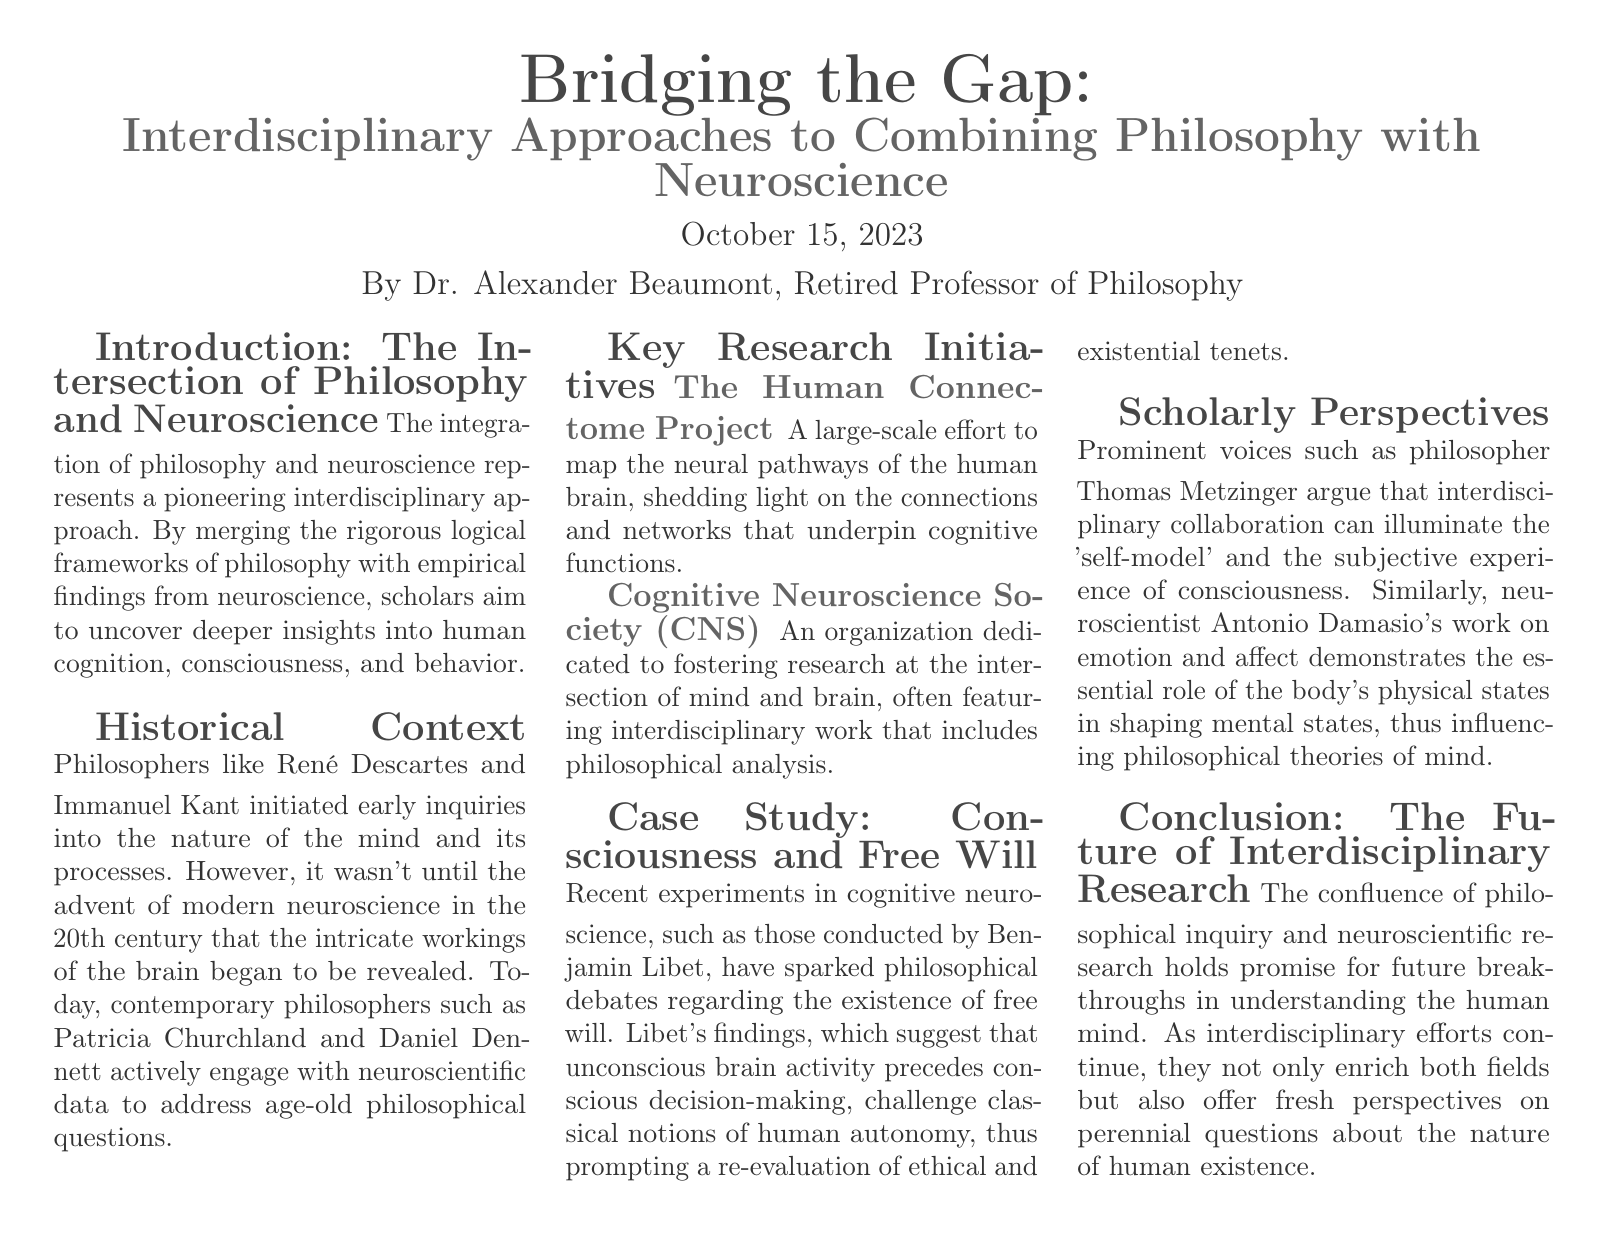What is the title of the article? The title of the article is presented at the top of the document.
Answer: Bridging the Gap: Interdisciplinary Approaches to Combining Philosophy with Neuroscience Who is the author of the article? The author is stated below the title and date.
Answer: Dr. Alexander Beaumont What historical figures initiated inquiries into the nature of the mind? The document lists these philosophers in the Historical Context section.
Answer: René Descartes and Immanuel Kant What project maps the neural pathways of the human brain? This information is found under the Key Research Initiatives section.
Answer: The Human Connectome Project Which society fosters research at the intersection of mind and brain? This is mentioned in the Key Research Initiatives section.
Answer: Cognitive Neuroscience Society (CNS) What philosophical debate is sparked by Benjamin Libet's experiments? The document discusses this in the Case Study section.
Answer: Free will Who argues for interdisciplinary collaboration to illuminate the 'self-model'? This person's perspective is mentioned in the Scholarly Perspectives section.
Answer: Thomas Metzinger What does the future of interdisciplinary research promise? The conclusion summarizes the potential outcomes of this collaboration.
Answer: Breakthroughs in understanding the human mind What date was the article published? The publication date is mentioned directly under the title.
Answer: October 15, 2023 